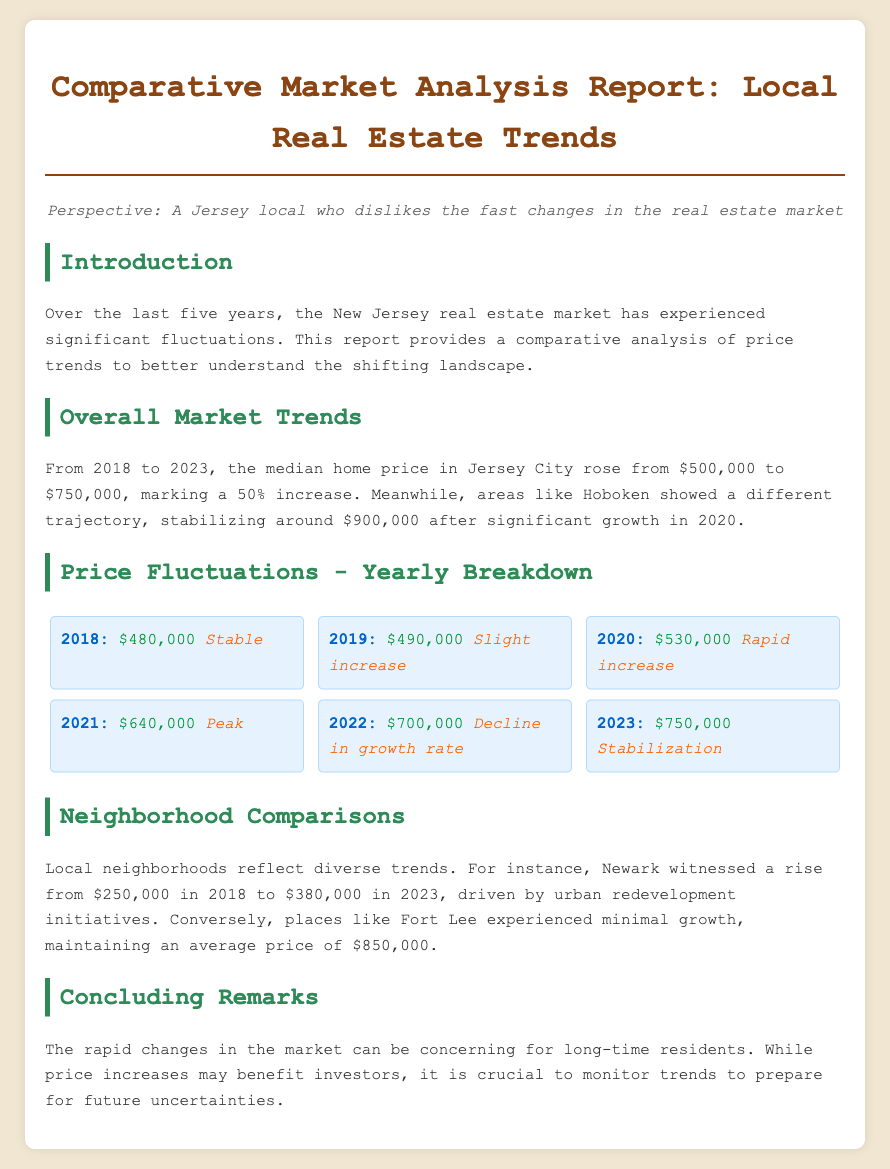What was the median home price in 2018? The document states that the median home price in 2018 was $480,000.
Answer: $480,000 What is the price trend for 2021? According to the report, the trend for 2021 indicates a peak.
Answer: Peak How much did the median home price rise from 2018 to 2023? The report indicates a rise of $250,000, from $500,000 to $750,000.
Answer: $250,000 What was Newark's home price in 2018? The document notes that Newark's home price in 2018 was $250,000.
Answer: $250,000 What was the average price in Fort Lee? The report mentions that Fort Lee maintained an average price of $850,000.
Answer: $850,000 What trend does the report note for 2022? The trend for 2022 is described as a decline in growth rate.
Answer: Decline in growth rate What neighborhood stabilized around $900,000? Hoboken is the neighborhood mentioned to have stabilized around $900,000.
Answer: Hoboken What was the price in 2023? The document states that the median home price in 2023 is $750,000.
Answer: $750,000 What is a concern for long-time residents according to the report? The report lists rapid changes in the market as a concern for long-time residents.
Answer: Rapid changes in the market 